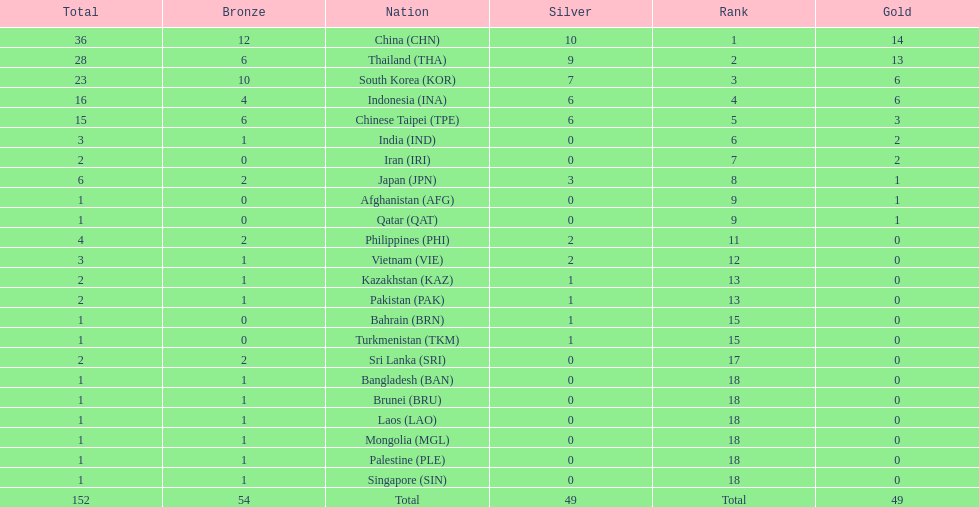How many combined silver medals did china, india, and japan earn ? 13. 